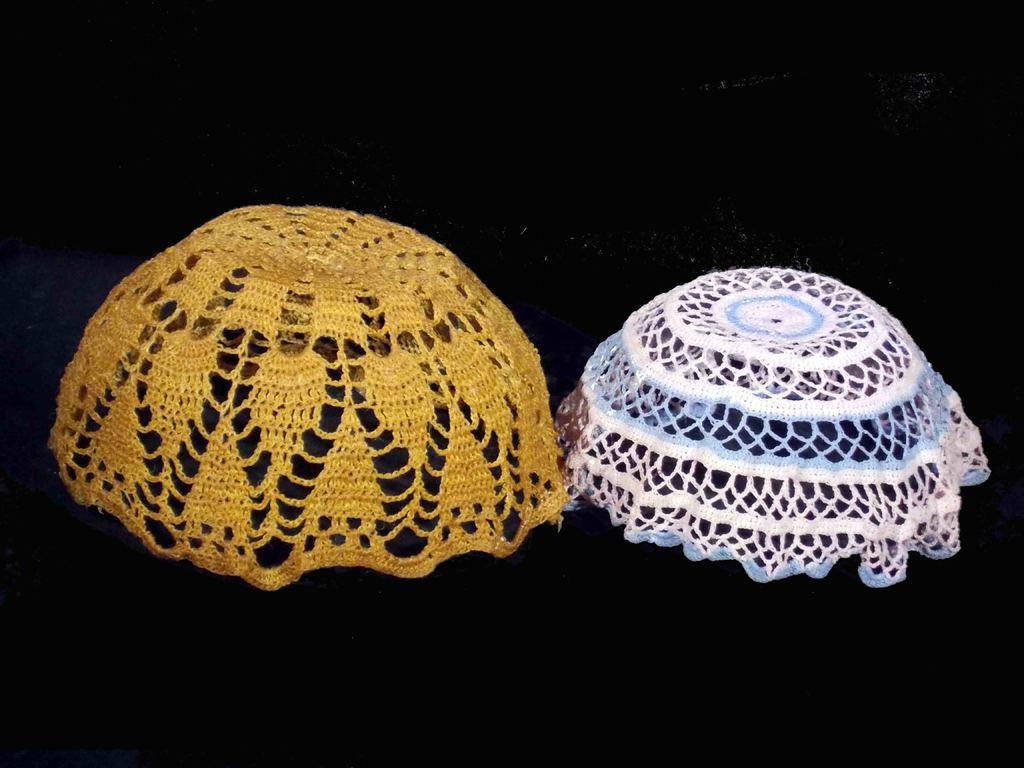Describe this image in one or two sentences. In this image, we can see woven baskets on the black surface. 